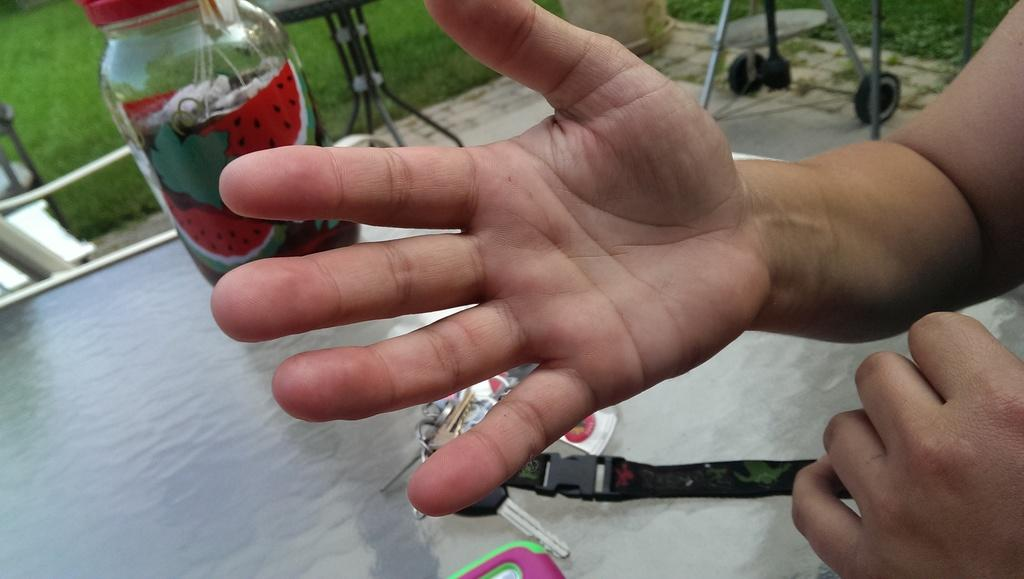What body part is visible in the image? There are hands visible in the image. What object can be seen in the image that is often used to unlock doors? There is a key in the image. What object can be seen in the image that is often used to hold liquids? There is a bottle in the image. What type of surface are the objects placed on in the image? There are objects on a surface in the image. What type of vegetation can be seen in the background of the image? There is grass visible in the background of the image. What type of furniture can be seen in the background of the image? There is a table in the background of the image. How many eggs are visible in the image? There are no eggs present in the image. What type of headwear is the person wearing in the image? There is no person or headwear visible in the image. 